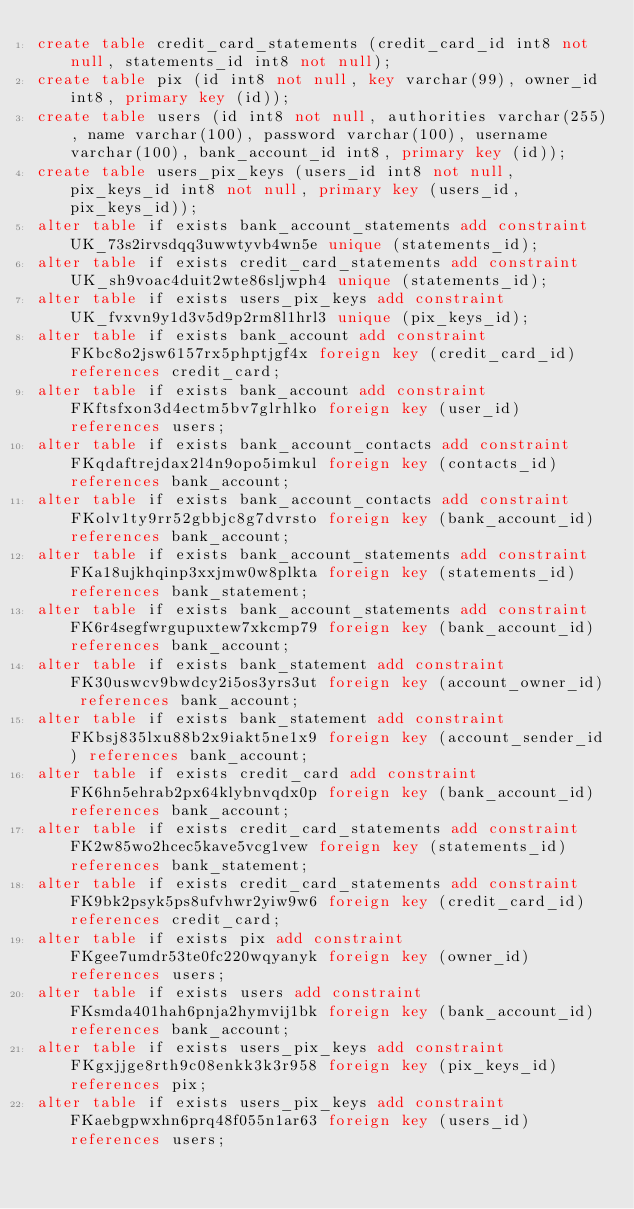<code> <loc_0><loc_0><loc_500><loc_500><_SQL_>create table credit_card_statements (credit_card_id int8 not null, statements_id int8 not null);
create table pix (id int8 not null, key varchar(99), owner_id int8, primary key (id));
create table users (id int8 not null, authorities varchar(255), name varchar(100), password varchar(100), username varchar(100), bank_account_id int8, primary key (id));
create table users_pix_keys (users_id int8 not null, pix_keys_id int8 not null, primary key (users_id, pix_keys_id));
alter table if exists bank_account_statements add constraint UK_73s2irvsdqq3uwwtyvb4wn5e unique (statements_id);
alter table if exists credit_card_statements add constraint UK_sh9voac4duit2wte86sljwph4 unique (statements_id);
alter table if exists users_pix_keys add constraint UK_fvxvn9y1d3v5d9p2rm8l1hrl3 unique (pix_keys_id);
alter table if exists bank_account add constraint FKbc8o2jsw6157rx5phptjgf4x foreign key (credit_card_id) references credit_card;
alter table if exists bank_account add constraint FKftsfxon3d4ectm5bv7glrhlko foreign key (user_id) references users;
alter table if exists bank_account_contacts add constraint FKqdaftrejdax2l4n9opo5imkul foreign key (contacts_id) references bank_account;
alter table if exists bank_account_contacts add constraint FKolv1ty9rr52gbbjc8g7dvrsto foreign key (bank_account_id) references bank_account;
alter table if exists bank_account_statements add constraint FKa18ujkhqinp3xxjmw0w8plkta foreign key (statements_id) references bank_statement;
alter table if exists bank_account_statements add constraint FK6r4segfwrgupuxtew7xkcmp79 foreign key (bank_account_id) references bank_account;
alter table if exists bank_statement add constraint FK30uswcv9bwdcy2i5os3yrs3ut foreign key (account_owner_id) references bank_account;
alter table if exists bank_statement add constraint FKbsj835lxu88b2x9iakt5ne1x9 foreign key (account_sender_id) references bank_account;
alter table if exists credit_card add constraint FK6hn5ehrab2px64klybnvqdx0p foreign key (bank_account_id) references bank_account;
alter table if exists credit_card_statements add constraint FK2w85wo2hcec5kave5vcg1vew foreign key (statements_id) references bank_statement;
alter table if exists credit_card_statements add constraint FK9bk2psyk5ps8ufvhwr2yiw9w6 foreign key (credit_card_id) references credit_card;
alter table if exists pix add constraint FKgee7umdr53te0fc220wqyanyk foreign key (owner_id) references users;
alter table if exists users add constraint FKsmda401hah6pnja2hymvij1bk foreign key (bank_account_id) references bank_account;
alter table if exists users_pix_keys add constraint FKgxjjge8rth9c08enkk3k3r958 foreign key (pix_keys_id) references pix;
alter table if exists users_pix_keys add constraint FKaebgpwxhn6prq48f055n1ar63 foreign key (users_id) references users;
</code> 